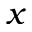<formula> <loc_0><loc_0><loc_500><loc_500>x</formula> 